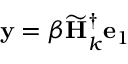Convert formula to latex. <formula><loc_0><loc_0><loc_500><loc_500>y = \beta \widetilde { H } _ { k } ^ { \dagger } e _ { 1 }</formula> 